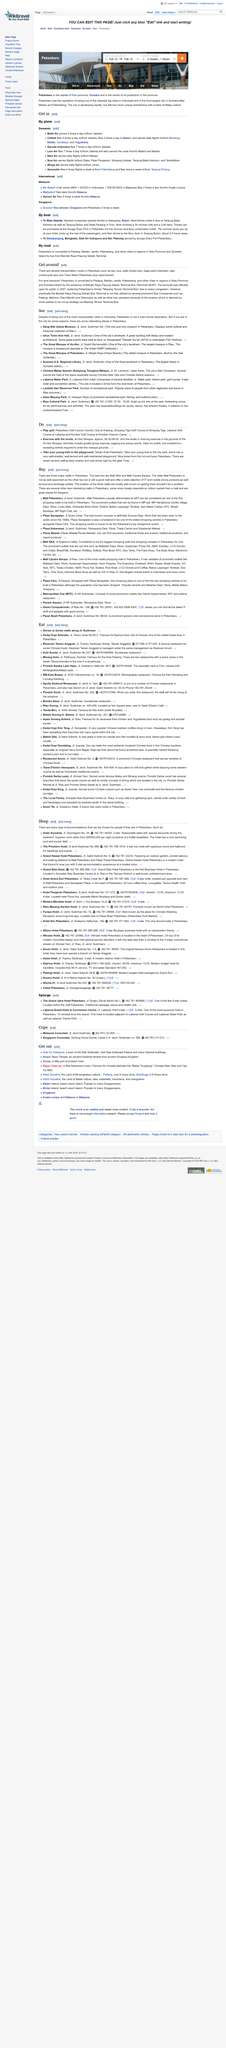Specify some key components in this picture. The land transport in Pekanbaru is connected to several cities, including Padang, Medan, Jambi, Palembang, and other locations in the Riau Province and Sumatra Island. There are several modes of transport available in Pekanbaru, including taxi, bus, oplet (shared taxi), bajaj (auto rickshaw), ojek (motorcycle taxi), and Trans Metro Pekanbaru (bus rapid transit). The Bandar Raya Payung Sekaki Terminal Bus was officially opened to the public in 2007. 